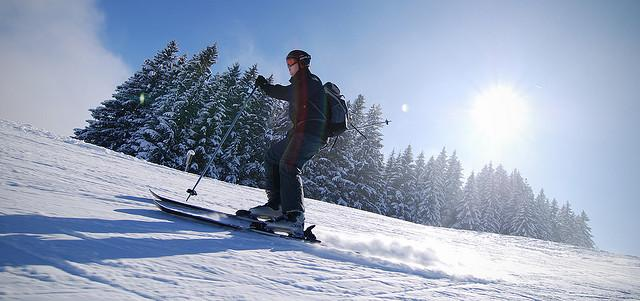What does the giant ball do?

Choices:
A) electrify
B) nuclear fusion
C) squeak
D) bounce nuclear fusion 